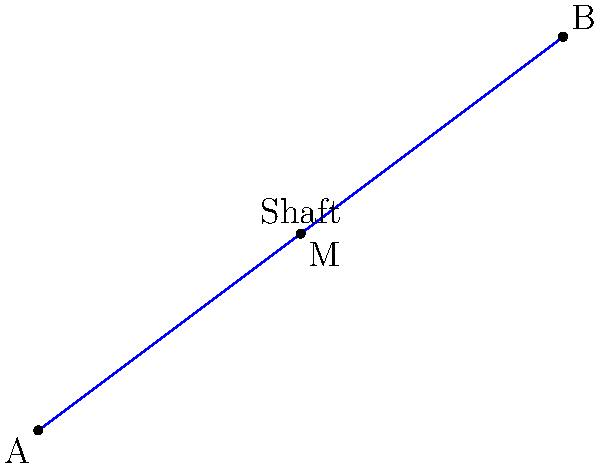In a classic persimmon wood driver, the shaft is represented by a line segment from point A(0,0) to point B(8,6) on a coordinate plane. If point M is the midpoint of the shaft, what are its coordinates? To find the midpoint of a line segment, we use the midpoint formula:

$$M_x = \frac{x_1 + x_2}{2}, M_y = \frac{y_1 + y_2}{2}$$

Where $(x_1, y_1)$ are the coordinates of point A, and $(x_2, y_2)$ are the coordinates of point B.

Given:
A(0,0) and B(8,6)

Step 1: Calculate the x-coordinate of the midpoint
$$M_x = \frac{0 + 8}{2} = \frac{8}{2} = 4$$

Step 2: Calculate the y-coordinate of the midpoint
$$M_y = \frac{0 + 6}{2} = \frac{6}{2} = 3$$

Therefore, the coordinates of the midpoint M are (4,3).
Answer: (4,3) 